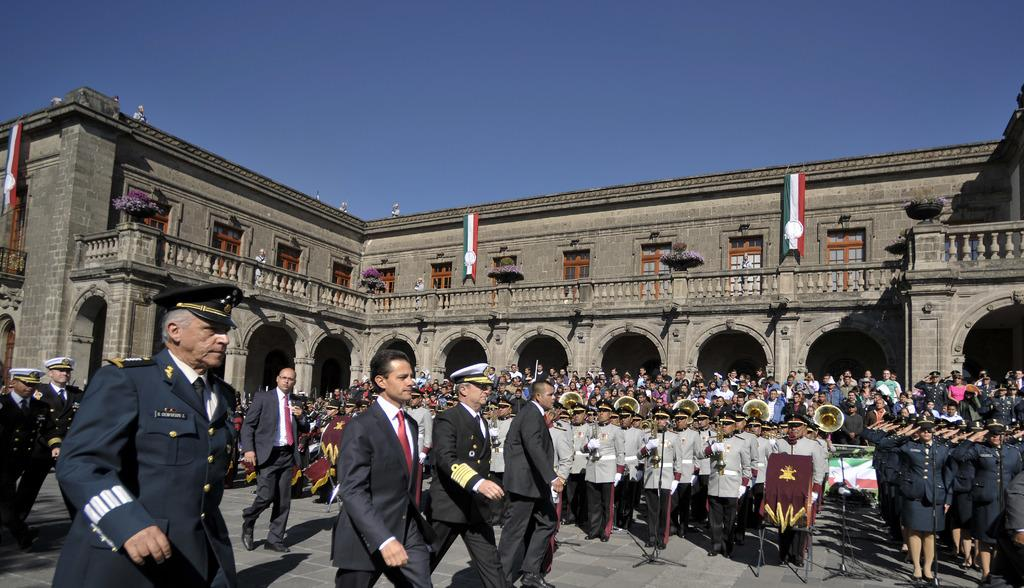Who or what is present in the image? There are people in the image. What are some of the people doing in the image? Some of the people are playing musical instruments. What else can be seen in the image besides the people? There are flags and house plants in the image. What can be seen in the background of the image? The sky is visible in the image. How does the magic affect the house plants in the image? There is no magic present in the image, so it cannot affect the house plants. 